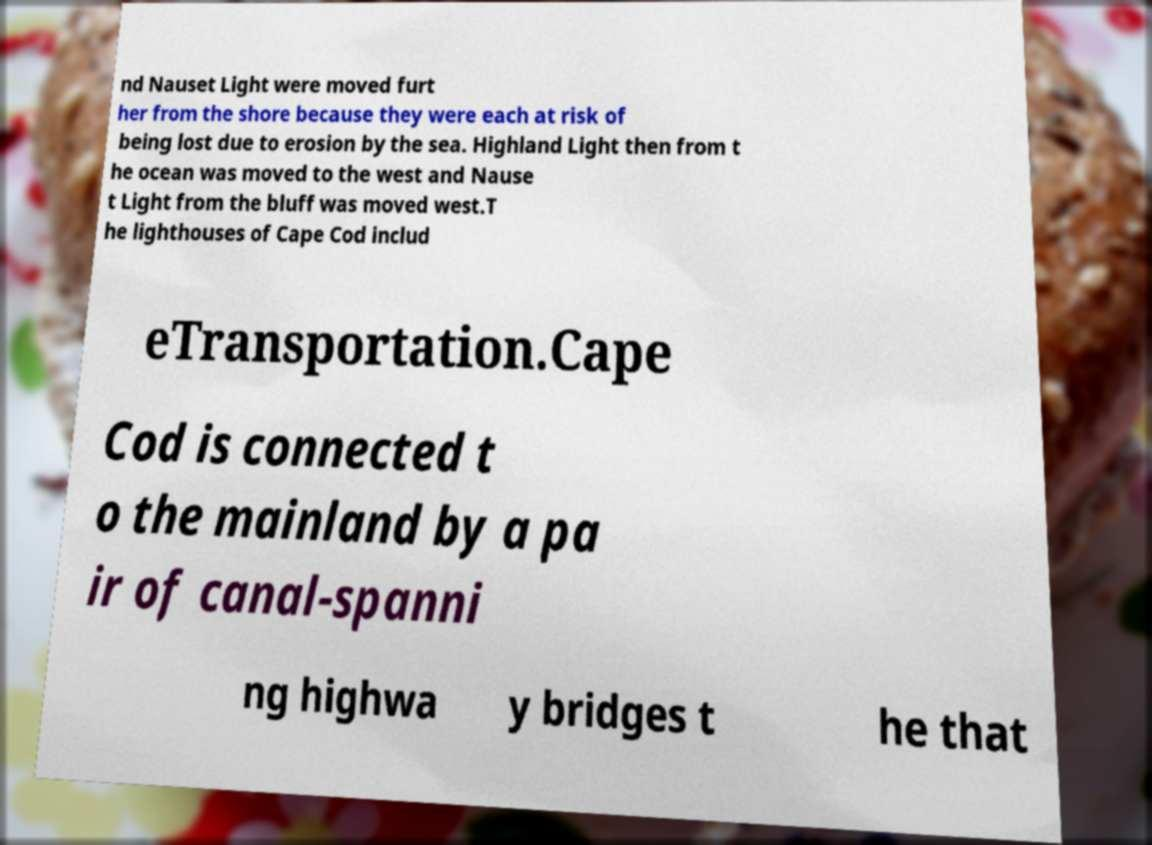There's text embedded in this image that I need extracted. Can you transcribe it verbatim? nd Nauset Light were moved furt her from the shore because they were each at risk of being lost due to erosion by the sea. Highland Light then from t he ocean was moved to the west and Nause t Light from the bluff was moved west.T he lighthouses of Cape Cod includ eTransportation.Cape Cod is connected t o the mainland by a pa ir of canal-spanni ng highwa y bridges t he that 